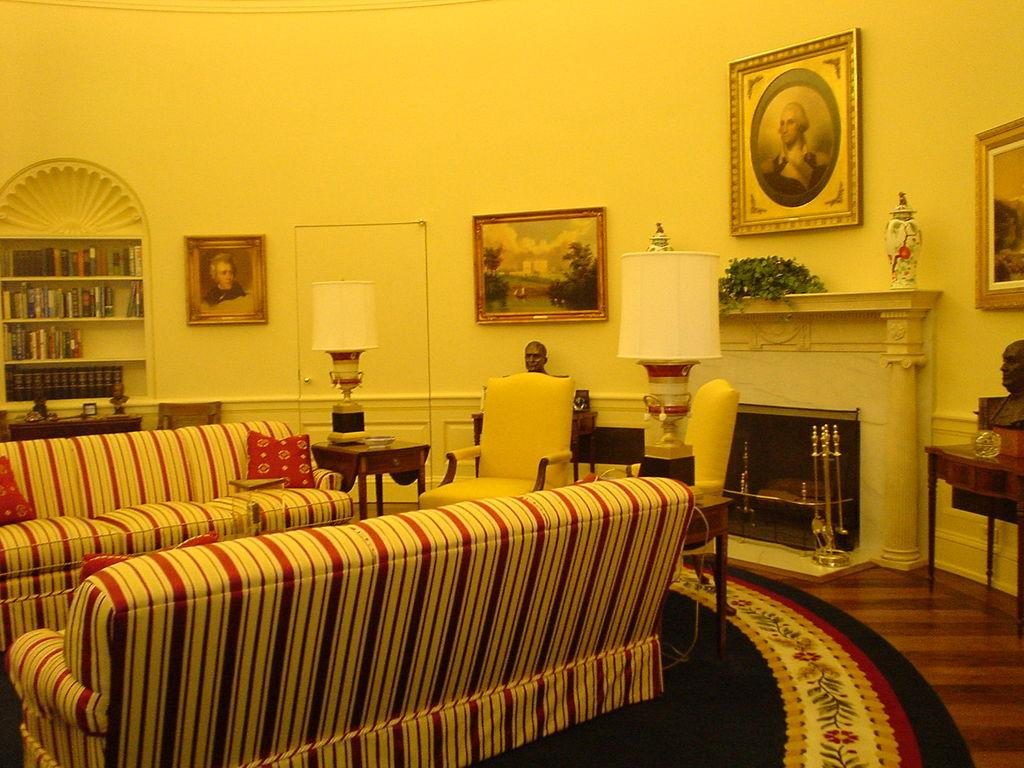What type of structure can be seen in the image? There is a wall in the image. What decorative item is present on the wall? There is a photo frame in the image. What type of lighting is visible in the image? There is a lamp in the image. What type of seating is present in the image? There is a sofa in the image. Who is in the photo frame? There is a person in the photo frame. What type of storage is present in the image? There are books in a shelf in the image. What type of furniture is present in the image? There is a table in the image. What type of plant is present in the image? There is a flower in the image. How many tables are visible in the image? There is another table in the image, making a total of two tables. How many ladybugs are crawling on the flower in the image? There are no ladybugs present in the image; only a flower is visible. What type of season is depicted in the image? The image does not depict a specific season, so it cannot be determined from the image. 